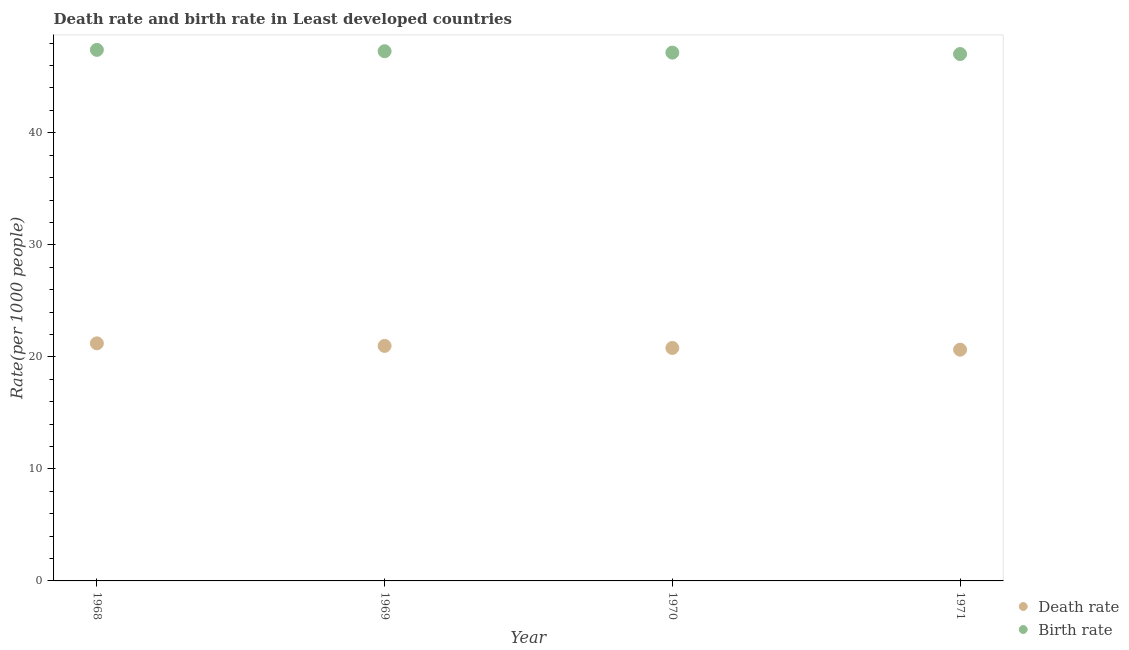How many different coloured dotlines are there?
Offer a very short reply. 2. Is the number of dotlines equal to the number of legend labels?
Provide a short and direct response. Yes. What is the death rate in 1969?
Your answer should be compact. 20.98. Across all years, what is the maximum death rate?
Offer a terse response. 21.21. Across all years, what is the minimum death rate?
Offer a terse response. 20.64. In which year was the death rate maximum?
Ensure brevity in your answer.  1968. In which year was the birth rate minimum?
Offer a terse response. 1971. What is the total birth rate in the graph?
Ensure brevity in your answer.  188.87. What is the difference between the birth rate in 1968 and that in 1971?
Your answer should be very brief. 0.37. What is the difference between the birth rate in 1968 and the death rate in 1970?
Your answer should be very brief. 26.61. What is the average birth rate per year?
Your answer should be compact. 47.22. In the year 1968, what is the difference between the death rate and birth rate?
Offer a terse response. -26.2. What is the ratio of the birth rate in 1968 to that in 1970?
Your answer should be compact. 1.01. Is the difference between the birth rate in 1968 and 1970 greater than the difference between the death rate in 1968 and 1970?
Provide a succinct answer. No. What is the difference between the highest and the second highest birth rate?
Ensure brevity in your answer.  0.12. What is the difference between the highest and the lowest death rate?
Keep it short and to the point. 0.56. In how many years, is the death rate greater than the average death rate taken over all years?
Keep it short and to the point. 2. Is the birth rate strictly greater than the death rate over the years?
Provide a short and direct response. Yes. Is the death rate strictly less than the birth rate over the years?
Give a very brief answer. Yes. How many dotlines are there?
Make the answer very short. 2. How many years are there in the graph?
Offer a terse response. 4. Where does the legend appear in the graph?
Your response must be concise. Bottom right. How many legend labels are there?
Your response must be concise. 2. What is the title of the graph?
Provide a succinct answer. Death rate and birth rate in Least developed countries. What is the label or title of the X-axis?
Your answer should be very brief. Year. What is the label or title of the Y-axis?
Make the answer very short. Rate(per 1000 people). What is the Rate(per 1000 people) in Death rate in 1968?
Give a very brief answer. 21.21. What is the Rate(per 1000 people) in Birth rate in 1968?
Make the answer very short. 47.4. What is the Rate(per 1000 people) of Death rate in 1969?
Provide a short and direct response. 20.98. What is the Rate(per 1000 people) of Birth rate in 1969?
Make the answer very short. 47.28. What is the Rate(per 1000 people) of Death rate in 1970?
Provide a succinct answer. 20.79. What is the Rate(per 1000 people) in Birth rate in 1970?
Provide a succinct answer. 47.16. What is the Rate(per 1000 people) of Death rate in 1971?
Keep it short and to the point. 20.64. What is the Rate(per 1000 people) of Birth rate in 1971?
Offer a terse response. 47.03. Across all years, what is the maximum Rate(per 1000 people) in Death rate?
Your answer should be very brief. 21.21. Across all years, what is the maximum Rate(per 1000 people) in Birth rate?
Provide a succinct answer. 47.4. Across all years, what is the minimum Rate(per 1000 people) in Death rate?
Your answer should be very brief. 20.64. Across all years, what is the minimum Rate(per 1000 people) of Birth rate?
Provide a succinct answer. 47.03. What is the total Rate(per 1000 people) in Death rate in the graph?
Provide a short and direct response. 83.62. What is the total Rate(per 1000 people) of Birth rate in the graph?
Offer a very short reply. 188.87. What is the difference between the Rate(per 1000 people) in Death rate in 1968 and that in 1969?
Give a very brief answer. 0.23. What is the difference between the Rate(per 1000 people) in Birth rate in 1968 and that in 1969?
Offer a terse response. 0.12. What is the difference between the Rate(per 1000 people) of Death rate in 1968 and that in 1970?
Make the answer very short. 0.41. What is the difference between the Rate(per 1000 people) in Birth rate in 1968 and that in 1970?
Make the answer very short. 0.25. What is the difference between the Rate(per 1000 people) in Death rate in 1968 and that in 1971?
Your answer should be compact. 0.56. What is the difference between the Rate(per 1000 people) of Birth rate in 1968 and that in 1971?
Your answer should be compact. 0.37. What is the difference between the Rate(per 1000 people) of Death rate in 1969 and that in 1970?
Offer a terse response. 0.18. What is the difference between the Rate(per 1000 people) in Birth rate in 1969 and that in 1970?
Provide a succinct answer. 0.12. What is the difference between the Rate(per 1000 people) in Death rate in 1969 and that in 1971?
Ensure brevity in your answer.  0.34. What is the difference between the Rate(per 1000 people) in Birth rate in 1969 and that in 1971?
Make the answer very short. 0.25. What is the difference between the Rate(per 1000 people) in Death rate in 1970 and that in 1971?
Keep it short and to the point. 0.15. What is the difference between the Rate(per 1000 people) in Birth rate in 1970 and that in 1971?
Offer a very short reply. 0.13. What is the difference between the Rate(per 1000 people) of Death rate in 1968 and the Rate(per 1000 people) of Birth rate in 1969?
Your answer should be compact. -26.08. What is the difference between the Rate(per 1000 people) in Death rate in 1968 and the Rate(per 1000 people) in Birth rate in 1970?
Provide a succinct answer. -25.95. What is the difference between the Rate(per 1000 people) of Death rate in 1968 and the Rate(per 1000 people) of Birth rate in 1971?
Your answer should be compact. -25.82. What is the difference between the Rate(per 1000 people) in Death rate in 1969 and the Rate(per 1000 people) in Birth rate in 1970?
Offer a very short reply. -26.18. What is the difference between the Rate(per 1000 people) of Death rate in 1969 and the Rate(per 1000 people) of Birth rate in 1971?
Your answer should be compact. -26.05. What is the difference between the Rate(per 1000 people) of Death rate in 1970 and the Rate(per 1000 people) of Birth rate in 1971?
Provide a short and direct response. -26.24. What is the average Rate(per 1000 people) in Death rate per year?
Ensure brevity in your answer.  20.91. What is the average Rate(per 1000 people) of Birth rate per year?
Your answer should be very brief. 47.22. In the year 1968, what is the difference between the Rate(per 1000 people) in Death rate and Rate(per 1000 people) in Birth rate?
Keep it short and to the point. -26.2. In the year 1969, what is the difference between the Rate(per 1000 people) in Death rate and Rate(per 1000 people) in Birth rate?
Your answer should be compact. -26.3. In the year 1970, what is the difference between the Rate(per 1000 people) of Death rate and Rate(per 1000 people) of Birth rate?
Make the answer very short. -26.36. In the year 1971, what is the difference between the Rate(per 1000 people) of Death rate and Rate(per 1000 people) of Birth rate?
Provide a succinct answer. -26.39. What is the ratio of the Rate(per 1000 people) of Death rate in 1968 to that in 1969?
Offer a terse response. 1.01. What is the ratio of the Rate(per 1000 people) of Birth rate in 1968 to that in 1969?
Keep it short and to the point. 1. What is the ratio of the Rate(per 1000 people) of Death rate in 1968 to that in 1970?
Ensure brevity in your answer.  1.02. What is the ratio of the Rate(per 1000 people) in Death rate in 1968 to that in 1971?
Keep it short and to the point. 1.03. What is the ratio of the Rate(per 1000 people) in Birth rate in 1968 to that in 1971?
Keep it short and to the point. 1.01. What is the ratio of the Rate(per 1000 people) in Death rate in 1969 to that in 1970?
Your answer should be very brief. 1.01. What is the ratio of the Rate(per 1000 people) of Death rate in 1969 to that in 1971?
Offer a very short reply. 1.02. What is the ratio of the Rate(per 1000 people) in Death rate in 1970 to that in 1971?
Provide a succinct answer. 1.01. What is the difference between the highest and the second highest Rate(per 1000 people) in Death rate?
Make the answer very short. 0.23. What is the difference between the highest and the second highest Rate(per 1000 people) of Birth rate?
Offer a very short reply. 0.12. What is the difference between the highest and the lowest Rate(per 1000 people) of Death rate?
Provide a short and direct response. 0.56. What is the difference between the highest and the lowest Rate(per 1000 people) in Birth rate?
Make the answer very short. 0.37. 